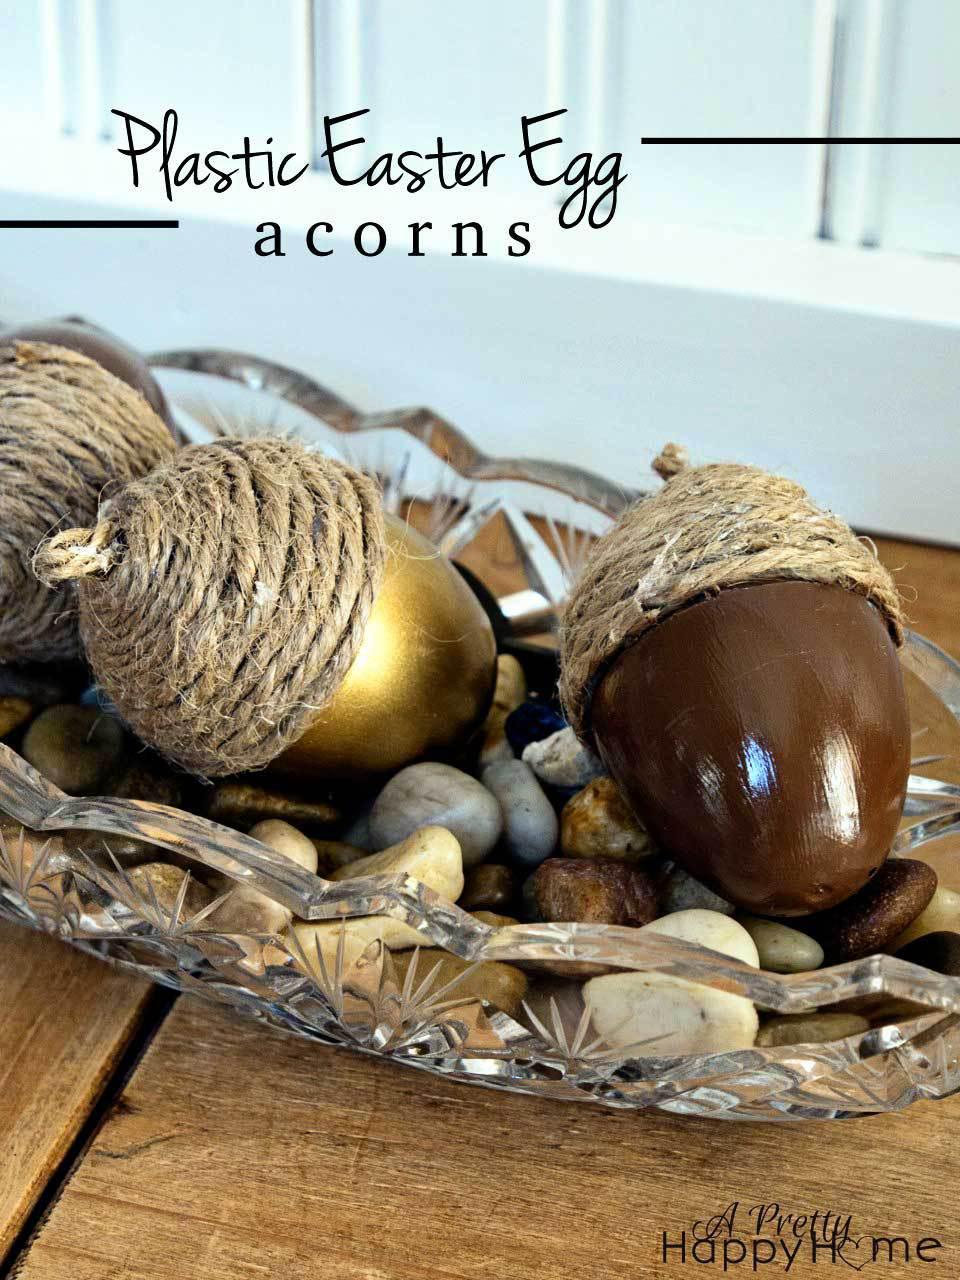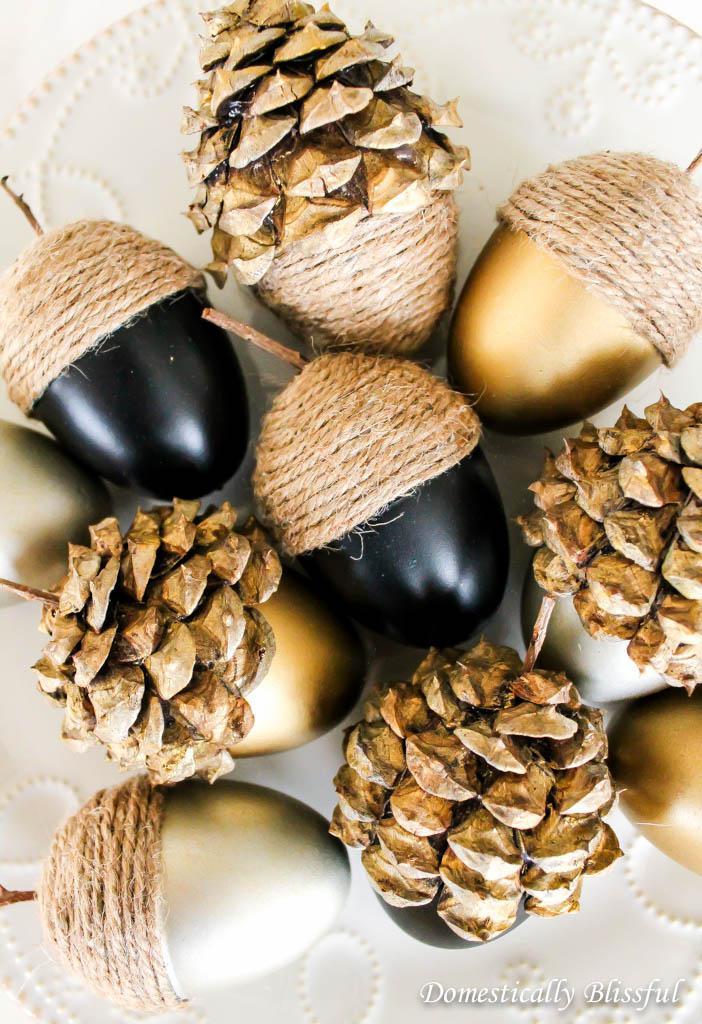The first image is the image on the left, the second image is the image on the right. Examine the images to the left and right. Is the description "The acorns in the left image are in a glass dish." accurate? Answer yes or no. Yes. The first image is the image on the left, the second image is the image on the right. Considering the images on both sides, is "The left image shows two 'acorn eggs' - one gold and one brown - in an oblong scalloped glass bowl containing smooth stones." valid? Answer yes or no. Yes. 